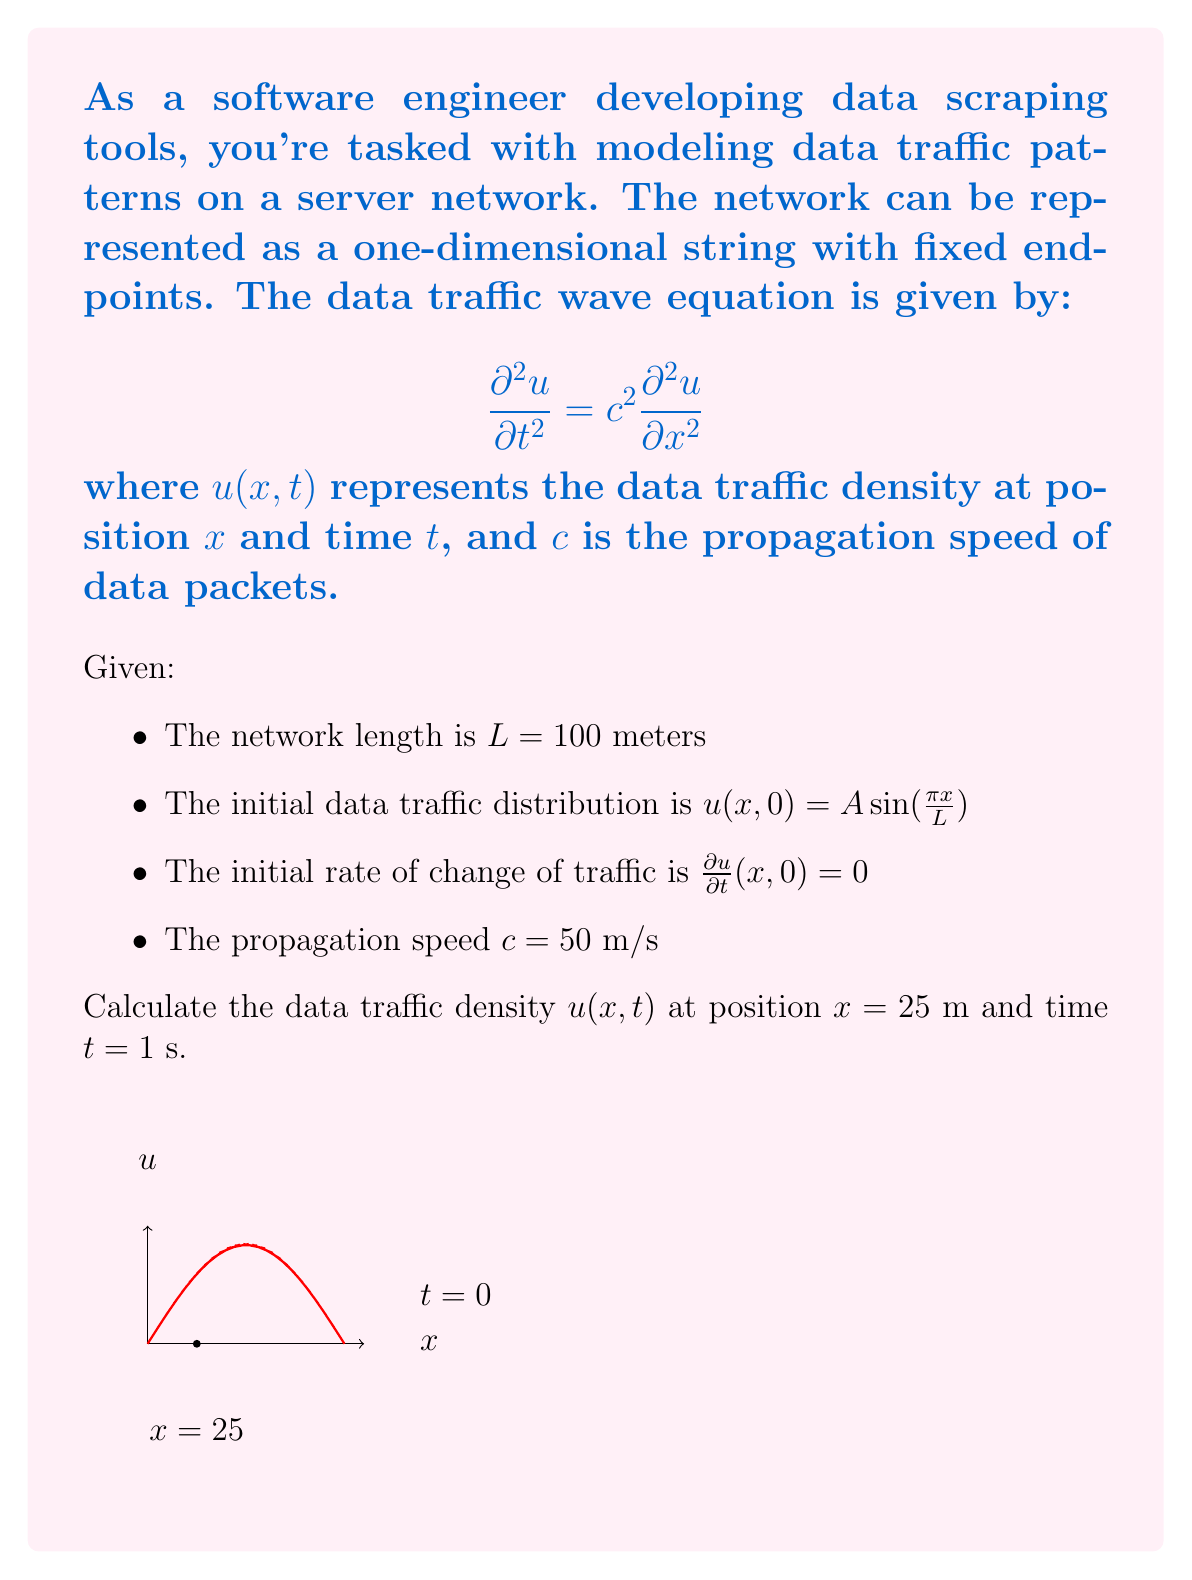Teach me how to tackle this problem. To solve this problem, we'll use the method of separation of variables:

1) The general solution for the wave equation with fixed endpoints is:

   $$u(x,t) = \sum_{n=1}^{\infty} (A_n \cos(\frac{n\pi c t}{L}) + B_n \sin(\frac{n\pi c t}{L})) \sin(\frac{n\pi x}{L})$$

2) Given the initial condition $u(x,0) = A \sin(\frac{\pi x}{L})$, we can see that only the first term (n=1) in the series is non-zero, and $A_1 = A$.

3) The initial rate of change condition $\frac{\partial u}{\partial t}(x,0) = 0$ implies that $B_1 = 0$.

4) Therefore, our solution simplifies to:

   $$u(x,t) = A \cos(\frac{\pi c t}{L}) \sin(\frac{\pi x}{L})$$

5) Now, let's substitute the given values:
   - $L = 100$ m
   - $c = 50$ m/s
   - $x = 25$ m
   - $t = 1$ s

6) $$u(25,1) = A \cos(\frac{\pi \cdot 50 \cdot 1}{100}) \sin(\frac{\pi \cdot 25}{100})$$

7) Simplify:
   $$u(25,1) = A \cos(\frac{\pi}{2}) \sin(\frac{\pi}{4})$$

8) $\cos(\frac{\pi}{2}) = 0$ and $\sin(\frac{\pi}{4}) = \frac{\sqrt{2}}{2}$

9) Therefore:
   $$u(25,1) = A \cdot 0 \cdot \frac{\sqrt{2}}{2} = 0$$

The data traffic density at $x = 25$ m and $t = 1$ s is zero, regardless of the initial amplitude $A$.
Answer: $u(25,1) = 0$ 